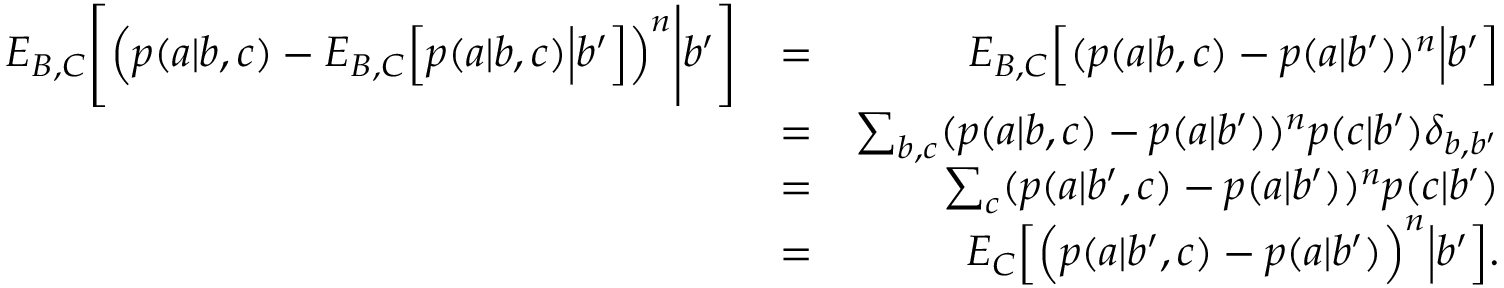<formula> <loc_0><loc_0><loc_500><loc_500>\begin{array} { r l r } { { E } _ { B , C } \left [ \left ( p ( a | b , c ) - { E } _ { B , C } \left [ p ( a | b , c ) \left | b ^ { \prime } \right ] \right ) ^ { n } \right | b ^ { \prime } \right ] } & { = } & { { E } _ { B , C } \left [ ( p ( a | b , c ) - p ( a | b ^ { \prime } ) ) ^ { n } \left | b ^ { \prime } \right ] } \\ & { = } & { \sum _ { b , c } ( p ( a | b , c ) - p ( a | b ^ { \prime } ) ) ^ { n } p ( c | b ^ { \prime } ) \delta _ { b , b ^ { \prime } } } \\ & { = } & { \sum _ { c } ( p ( a | b ^ { \prime } , c ) - p ( a | b ^ { \prime } ) ) ^ { n } p ( c | b ^ { \prime } ) } \\ & { = } & { { E } _ { C } \left [ \left ( p ( a | b ^ { \prime } , c ) - p ( a | b ^ { \prime } ) \right ) ^ { n } \right | b ^ { \prime } \right ] . } \end{array}</formula> 